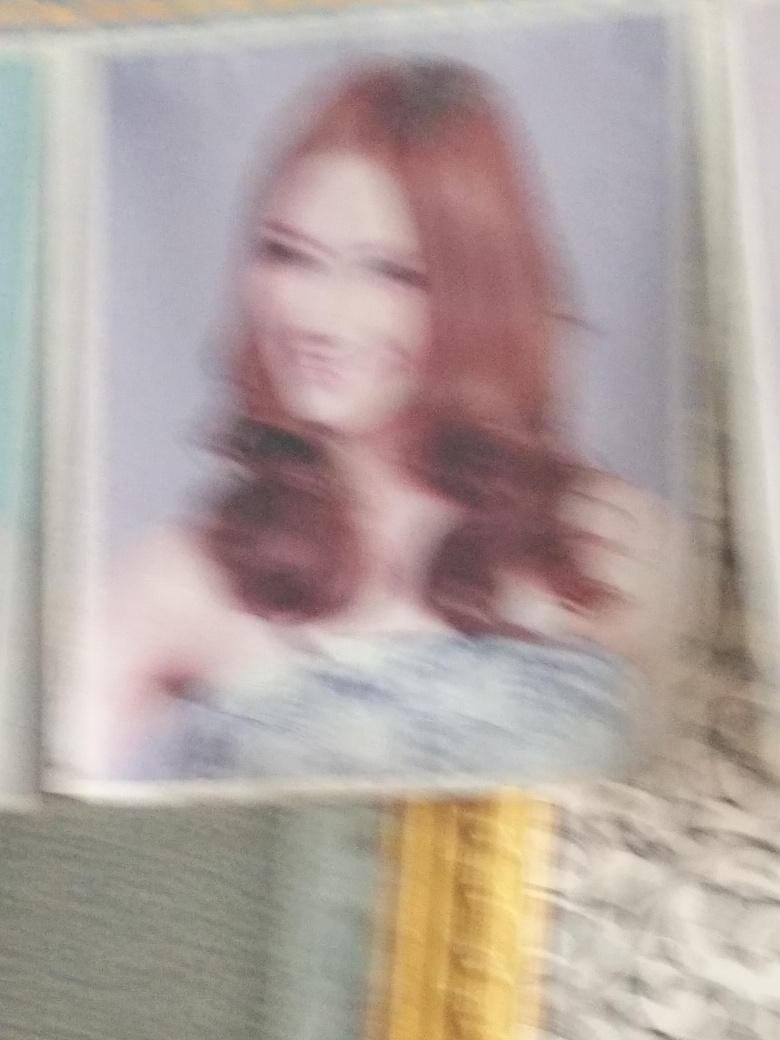Can you infer anything about the setting or location where this picture might have been taken? Given the image's blurred state, concrete details about the setting or location are not discernible. However, the presence of a soft background suggests an indoor environment or a studio, where portrait photography often takes place. The lack of harsh lighting or shadows could imply a controlled lighting situation typical of such settings. 